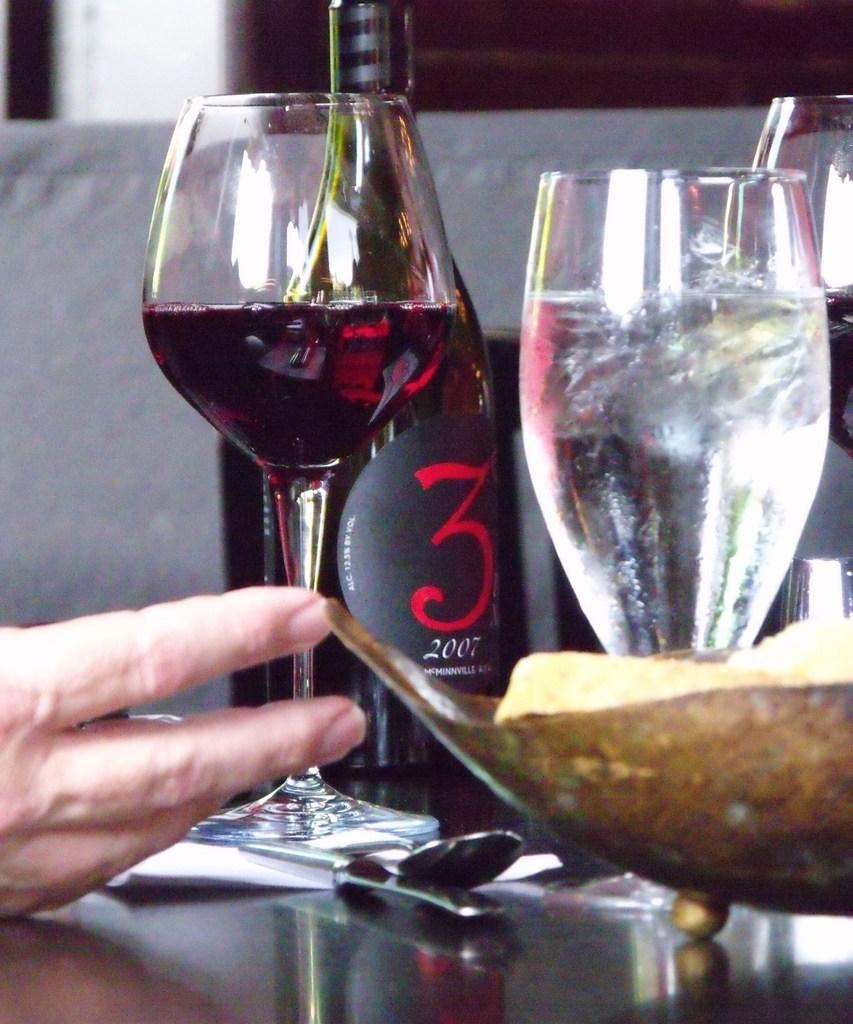What type of glasses are present in the image? There are wine glasses in the image. What is the wine glasses' purpose? The wine glasses are used for holding wine. What is the wine bottle's purpose? The wine bottle is used for holding wine. Where are the wine glasses and wine bottle located? The wine glasses and wine bottle are on a table. What else is on the table in the image? There is a human hand and a bowl visible in the image. What type of fuel is being used to light the candles in the image? There are no candles present in the image, so fuel is not being used for lighting anything. 